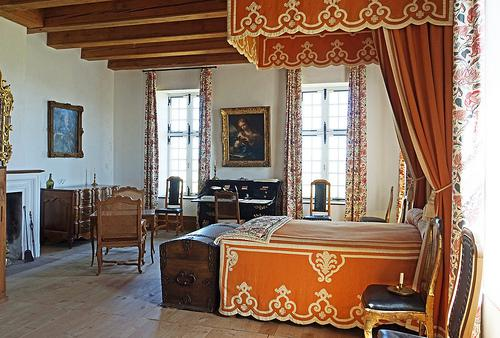Question: who is this style bed named after?
Choices:
A. King George.
B. Queen Elizabeth.
C. King Louis, the Sun King.
D. Prince Edward.
Answer with the letter. Answer: C Question: what is across the ceiling?
Choices:
A. Paint stripes.
B. Texture.
C. Spiderwebs.
D. Wood beams.
Answer with the letter. Answer: D Question: where is the portrait in the gold frame?
Choices:
A. On the wall.
B. On the desk.
C. Above the desk.
D. On the floor.
Answer with the letter. Answer: C Question: how many chairs are seen in the room?
Choices:
A. Less than ten.
B. More than four.
C. At least 8.
D. About twelve.
Answer with the letter. Answer: C Question: where would a person keep their clothes in a room like this?
Choices:
A. Closet.
B. Suitcase.
C. Plastic totes.
D. In an armoire or chest of drawers.
Answer with the letter. Answer: D Question: what kind of flooring does the room have?
Choices:
A. Ceramic tile.
B. Bamboo.
C. Wood plank.
D. Carpet.
Answer with the letter. Answer: C 